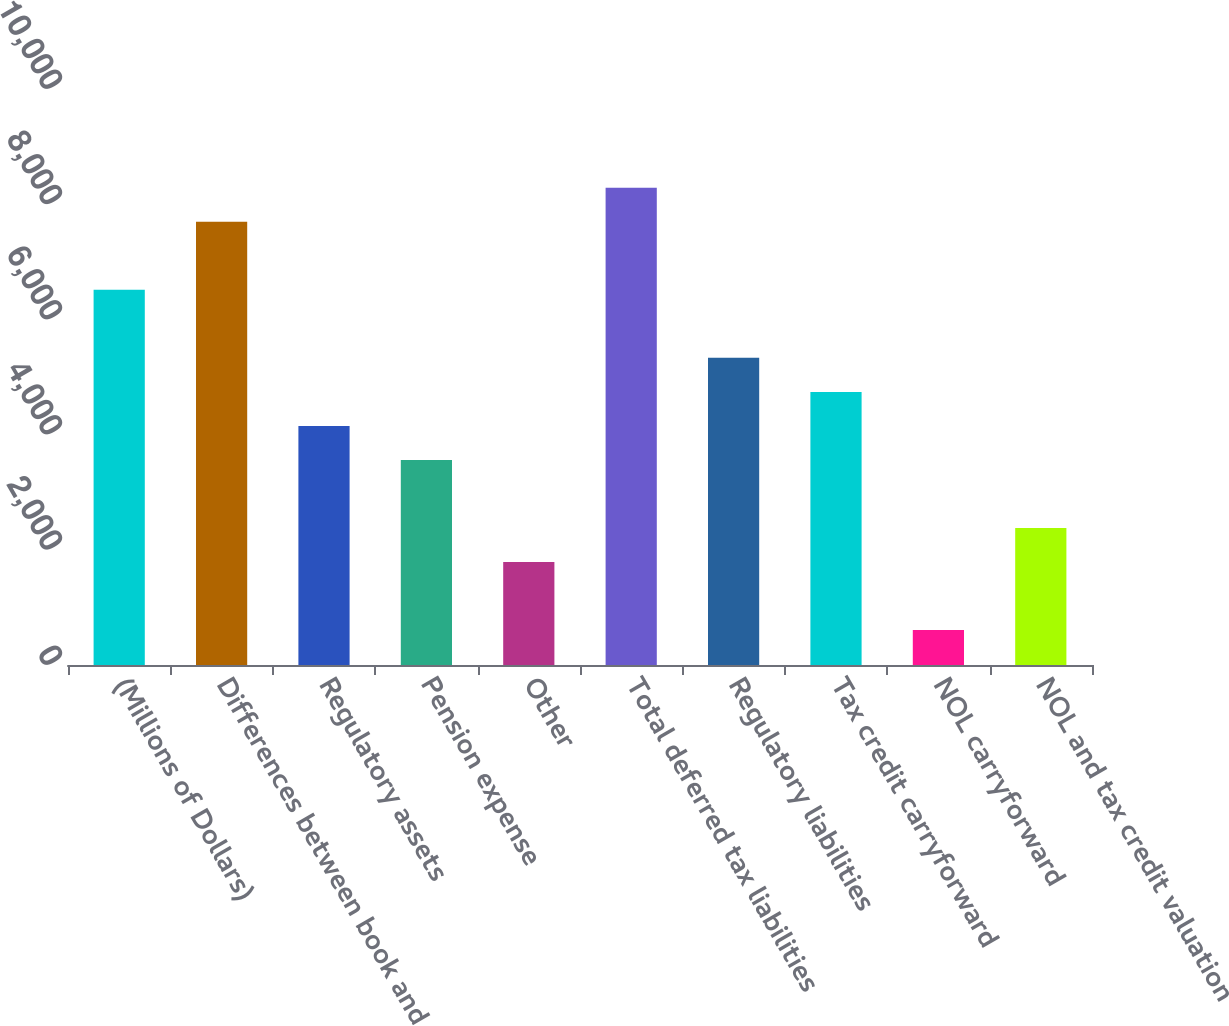Convert chart to OTSL. <chart><loc_0><loc_0><loc_500><loc_500><bar_chart><fcel>(Millions of Dollars)<fcel>Differences between book and<fcel>Regulatory assets<fcel>Pension expense<fcel>Other<fcel>Total deferred tax liabilities<fcel>Regulatory liabilities<fcel>Tax credit carryforward<fcel>NOL carryforward<fcel>NOL and tax credit valuation<nl><fcel>6513.7<fcel>7695.1<fcel>4150.9<fcel>3560.2<fcel>1788.1<fcel>8285.8<fcel>5332.3<fcel>4741.6<fcel>606.7<fcel>2378.8<nl></chart> 